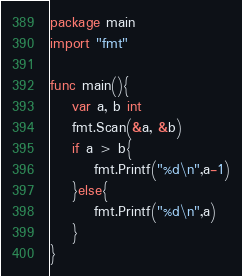<code> <loc_0><loc_0><loc_500><loc_500><_Go_>package main
import "fmt"

func main(){
	var a, b int
	fmt.Scan(&a, &b)
	if a > b{
		fmt.Printf("%d\n",a-1)
	}else{
		fmt.Printf("%d\n",a)
	}
}</code> 